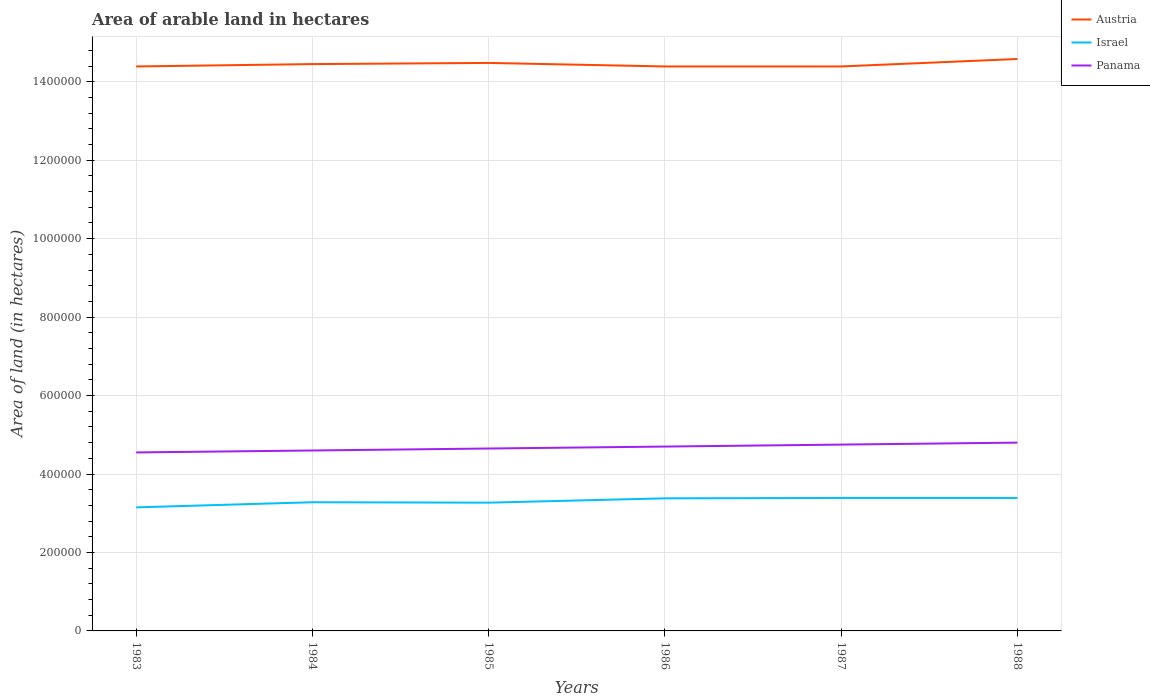Across all years, what is the maximum total arable land in Panama?
Give a very brief answer. 4.55e+05. In which year was the total arable land in Israel maximum?
Your response must be concise. 1983. What is the total total arable land in Austria in the graph?
Provide a succinct answer. -1.30e+04. What is the difference between the highest and the second highest total arable land in Israel?
Provide a succinct answer. 2.40e+04. What is the difference between the highest and the lowest total arable land in Israel?
Offer a terse response. 3. How many years are there in the graph?
Your response must be concise. 6. Does the graph contain any zero values?
Your response must be concise. No. Does the graph contain grids?
Your answer should be very brief. Yes. Where does the legend appear in the graph?
Your answer should be very brief. Top right. How are the legend labels stacked?
Offer a terse response. Vertical. What is the title of the graph?
Offer a very short reply. Area of arable land in hectares. Does "Faeroe Islands" appear as one of the legend labels in the graph?
Offer a very short reply. No. What is the label or title of the Y-axis?
Ensure brevity in your answer.  Area of land (in hectares). What is the Area of land (in hectares) of Austria in 1983?
Ensure brevity in your answer.  1.44e+06. What is the Area of land (in hectares) of Israel in 1983?
Offer a very short reply. 3.15e+05. What is the Area of land (in hectares) in Panama in 1983?
Ensure brevity in your answer.  4.55e+05. What is the Area of land (in hectares) in Austria in 1984?
Make the answer very short. 1.44e+06. What is the Area of land (in hectares) of Israel in 1984?
Offer a terse response. 3.28e+05. What is the Area of land (in hectares) of Austria in 1985?
Provide a succinct answer. 1.45e+06. What is the Area of land (in hectares) in Israel in 1985?
Give a very brief answer. 3.27e+05. What is the Area of land (in hectares) of Panama in 1985?
Give a very brief answer. 4.65e+05. What is the Area of land (in hectares) in Austria in 1986?
Make the answer very short. 1.44e+06. What is the Area of land (in hectares) in Israel in 1986?
Your answer should be compact. 3.38e+05. What is the Area of land (in hectares) in Panama in 1986?
Ensure brevity in your answer.  4.70e+05. What is the Area of land (in hectares) in Austria in 1987?
Provide a short and direct response. 1.44e+06. What is the Area of land (in hectares) of Israel in 1987?
Keep it short and to the point. 3.39e+05. What is the Area of land (in hectares) in Panama in 1987?
Make the answer very short. 4.75e+05. What is the Area of land (in hectares) in Austria in 1988?
Make the answer very short. 1.46e+06. What is the Area of land (in hectares) of Israel in 1988?
Provide a succinct answer. 3.39e+05. What is the Area of land (in hectares) of Panama in 1988?
Give a very brief answer. 4.80e+05. Across all years, what is the maximum Area of land (in hectares) in Austria?
Provide a succinct answer. 1.46e+06. Across all years, what is the maximum Area of land (in hectares) of Israel?
Your response must be concise. 3.39e+05. Across all years, what is the minimum Area of land (in hectares) of Austria?
Offer a very short reply. 1.44e+06. Across all years, what is the minimum Area of land (in hectares) in Israel?
Make the answer very short. 3.15e+05. Across all years, what is the minimum Area of land (in hectares) in Panama?
Provide a short and direct response. 4.55e+05. What is the total Area of land (in hectares) in Austria in the graph?
Offer a very short reply. 8.67e+06. What is the total Area of land (in hectares) in Israel in the graph?
Your answer should be very brief. 1.99e+06. What is the total Area of land (in hectares) in Panama in the graph?
Your answer should be compact. 2.80e+06. What is the difference between the Area of land (in hectares) in Austria in 1983 and that in 1984?
Ensure brevity in your answer.  -6000. What is the difference between the Area of land (in hectares) of Israel in 1983 and that in 1984?
Provide a short and direct response. -1.30e+04. What is the difference between the Area of land (in hectares) of Panama in 1983 and that in 1984?
Offer a terse response. -5000. What is the difference between the Area of land (in hectares) of Austria in 1983 and that in 1985?
Your response must be concise. -9000. What is the difference between the Area of land (in hectares) in Israel in 1983 and that in 1985?
Keep it short and to the point. -1.20e+04. What is the difference between the Area of land (in hectares) in Panama in 1983 and that in 1985?
Keep it short and to the point. -10000. What is the difference between the Area of land (in hectares) of Austria in 1983 and that in 1986?
Provide a short and direct response. 0. What is the difference between the Area of land (in hectares) in Israel in 1983 and that in 1986?
Provide a succinct answer. -2.30e+04. What is the difference between the Area of land (in hectares) in Panama in 1983 and that in 1986?
Make the answer very short. -1.50e+04. What is the difference between the Area of land (in hectares) of Israel in 1983 and that in 1987?
Your answer should be very brief. -2.40e+04. What is the difference between the Area of land (in hectares) in Austria in 1983 and that in 1988?
Offer a very short reply. -1.90e+04. What is the difference between the Area of land (in hectares) of Israel in 1983 and that in 1988?
Ensure brevity in your answer.  -2.40e+04. What is the difference between the Area of land (in hectares) in Panama in 1983 and that in 1988?
Offer a terse response. -2.50e+04. What is the difference between the Area of land (in hectares) of Austria in 1984 and that in 1985?
Your response must be concise. -3000. What is the difference between the Area of land (in hectares) of Panama in 1984 and that in 1985?
Offer a terse response. -5000. What is the difference between the Area of land (in hectares) of Austria in 1984 and that in 1986?
Provide a succinct answer. 6000. What is the difference between the Area of land (in hectares) of Israel in 1984 and that in 1986?
Give a very brief answer. -10000. What is the difference between the Area of land (in hectares) in Panama in 1984 and that in 1986?
Your answer should be very brief. -10000. What is the difference between the Area of land (in hectares) of Austria in 1984 and that in 1987?
Give a very brief answer. 6000. What is the difference between the Area of land (in hectares) of Israel in 1984 and that in 1987?
Keep it short and to the point. -1.10e+04. What is the difference between the Area of land (in hectares) of Panama in 1984 and that in 1987?
Give a very brief answer. -1.50e+04. What is the difference between the Area of land (in hectares) of Austria in 1984 and that in 1988?
Provide a short and direct response. -1.30e+04. What is the difference between the Area of land (in hectares) in Israel in 1984 and that in 1988?
Keep it short and to the point. -1.10e+04. What is the difference between the Area of land (in hectares) of Austria in 1985 and that in 1986?
Provide a short and direct response. 9000. What is the difference between the Area of land (in hectares) of Israel in 1985 and that in 1986?
Offer a terse response. -1.10e+04. What is the difference between the Area of land (in hectares) of Panama in 1985 and that in 1986?
Your response must be concise. -5000. What is the difference between the Area of land (in hectares) in Austria in 1985 and that in 1987?
Your response must be concise. 9000. What is the difference between the Area of land (in hectares) of Israel in 1985 and that in 1987?
Your answer should be compact. -1.20e+04. What is the difference between the Area of land (in hectares) of Panama in 1985 and that in 1987?
Provide a succinct answer. -10000. What is the difference between the Area of land (in hectares) in Israel in 1985 and that in 1988?
Your answer should be very brief. -1.20e+04. What is the difference between the Area of land (in hectares) of Panama in 1985 and that in 1988?
Your response must be concise. -1.50e+04. What is the difference between the Area of land (in hectares) in Austria in 1986 and that in 1987?
Your response must be concise. 0. What is the difference between the Area of land (in hectares) in Israel in 1986 and that in 1987?
Provide a succinct answer. -1000. What is the difference between the Area of land (in hectares) in Panama in 1986 and that in 1987?
Provide a succinct answer. -5000. What is the difference between the Area of land (in hectares) of Austria in 1986 and that in 1988?
Ensure brevity in your answer.  -1.90e+04. What is the difference between the Area of land (in hectares) of Israel in 1986 and that in 1988?
Offer a terse response. -1000. What is the difference between the Area of land (in hectares) in Austria in 1987 and that in 1988?
Give a very brief answer. -1.90e+04. What is the difference between the Area of land (in hectares) in Panama in 1987 and that in 1988?
Offer a very short reply. -5000. What is the difference between the Area of land (in hectares) in Austria in 1983 and the Area of land (in hectares) in Israel in 1984?
Make the answer very short. 1.11e+06. What is the difference between the Area of land (in hectares) in Austria in 1983 and the Area of land (in hectares) in Panama in 1984?
Offer a terse response. 9.79e+05. What is the difference between the Area of land (in hectares) in Israel in 1983 and the Area of land (in hectares) in Panama in 1984?
Your answer should be compact. -1.45e+05. What is the difference between the Area of land (in hectares) in Austria in 1983 and the Area of land (in hectares) in Israel in 1985?
Your answer should be compact. 1.11e+06. What is the difference between the Area of land (in hectares) in Austria in 1983 and the Area of land (in hectares) in Panama in 1985?
Offer a very short reply. 9.74e+05. What is the difference between the Area of land (in hectares) of Israel in 1983 and the Area of land (in hectares) of Panama in 1985?
Offer a terse response. -1.50e+05. What is the difference between the Area of land (in hectares) in Austria in 1983 and the Area of land (in hectares) in Israel in 1986?
Give a very brief answer. 1.10e+06. What is the difference between the Area of land (in hectares) in Austria in 1983 and the Area of land (in hectares) in Panama in 1986?
Provide a succinct answer. 9.69e+05. What is the difference between the Area of land (in hectares) in Israel in 1983 and the Area of land (in hectares) in Panama in 1986?
Offer a very short reply. -1.55e+05. What is the difference between the Area of land (in hectares) of Austria in 1983 and the Area of land (in hectares) of Israel in 1987?
Offer a very short reply. 1.10e+06. What is the difference between the Area of land (in hectares) in Austria in 1983 and the Area of land (in hectares) in Panama in 1987?
Your response must be concise. 9.64e+05. What is the difference between the Area of land (in hectares) of Austria in 1983 and the Area of land (in hectares) of Israel in 1988?
Your answer should be compact. 1.10e+06. What is the difference between the Area of land (in hectares) in Austria in 1983 and the Area of land (in hectares) in Panama in 1988?
Provide a succinct answer. 9.59e+05. What is the difference between the Area of land (in hectares) in Israel in 1983 and the Area of land (in hectares) in Panama in 1988?
Keep it short and to the point. -1.65e+05. What is the difference between the Area of land (in hectares) in Austria in 1984 and the Area of land (in hectares) in Israel in 1985?
Ensure brevity in your answer.  1.12e+06. What is the difference between the Area of land (in hectares) in Austria in 1984 and the Area of land (in hectares) in Panama in 1985?
Offer a terse response. 9.80e+05. What is the difference between the Area of land (in hectares) in Israel in 1984 and the Area of land (in hectares) in Panama in 1985?
Make the answer very short. -1.37e+05. What is the difference between the Area of land (in hectares) in Austria in 1984 and the Area of land (in hectares) in Israel in 1986?
Your response must be concise. 1.11e+06. What is the difference between the Area of land (in hectares) of Austria in 1984 and the Area of land (in hectares) of Panama in 1986?
Your answer should be very brief. 9.75e+05. What is the difference between the Area of land (in hectares) of Israel in 1984 and the Area of land (in hectares) of Panama in 1986?
Your response must be concise. -1.42e+05. What is the difference between the Area of land (in hectares) in Austria in 1984 and the Area of land (in hectares) in Israel in 1987?
Ensure brevity in your answer.  1.11e+06. What is the difference between the Area of land (in hectares) in Austria in 1984 and the Area of land (in hectares) in Panama in 1987?
Offer a very short reply. 9.70e+05. What is the difference between the Area of land (in hectares) of Israel in 1984 and the Area of land (in hectares) of Panama in 1987?
Give a very brief answer. -1.47e+05. What is the difference between the Area of land (in hectares) in Austria in 1984 and the Area of land (in hectares) in Israel in 1988?
Your answer should be very brief. 1.11e+06. What is the difference between the Area of land (in hectares) of Austria in 1984 and the Area of land (in hectares) of Panama in 1988?
Ensure brevity in your answer.  9.65e+05. What is the difference between the Area of land (in hectares) of Israel in 1984 and the Area of land (in hectares) of Panama in 1988?
Your response must be concise. -1.52e+05. What is the difference between the Area of land (in hectares) of Austria in 1985 and the Area of land (in hectares) of Israel in 1986?
Provide a short and direct response. 1.11e+06. What is the difference between the Area of land (in hectares) of Austria in 1985 and the Area of land (in hectares) of Panama in 1986?
Give a very brief answer. 9.78e+05. What is the difference between the Area of land (in hectares) of Israel in 1985 and the Area of land (in hectares) of Panama in 1986?
Your answer should be very brief. -1.43e+05. What is the difference between the Area of land (in hectares) of Austria in 1985 and the Area of land (in hectares) of Israel in 1987?
Give a very brief answer. 1.11e+06. What is the difference between the Area of land (in hectares) in Austria in 1985 and the Area of land (in hectares) in Panama in 1987?
Offer a very short reply. 9.73e+05. What is the difference between the Area of land (in hectares) in Israel in 1985 and the Area of land (in hectares) in Panama in 1987?
Provide a succinct answer. -1.48e+05. What is the difference between the Area of land (in hectares) in Austria in 1985 and the Area of land (in hectares) in Israel in 1988?
Provide a short and direct response. 1.11e+06. What is the difference between the Area of land (in hectares) in Austria in 1985 and the Area of land (in hectares) in Panama in 1988?
Provide a short and direct response. 9.68e+05. What is the difference between the Area of land (in hectares) in Israel in 1985 and the Area of land (in hectares) in Panama in 1988?
Offer a very short reply. -1.53e+05. What is the difference between the Area of land (in hectares) of Austria in 1986 and the Area of land (in hectares) of Israel in 1987?
Provide a short and direct response. 1.10e+06. What is the difference between the Area of land (in hectares) of Austria in 1986 and the Area of land (in hectares) of Panama in 1987?
Your answer should be very brief. 9.64e+05. What is the difference between the Area of land (in hectares) in Israel in 1986 and the Area of land (in hectares) in Panama in 1987?
Offer a very short reply. -1.37e+05. What is the difference between the Area of land (in hectares) in Austria in 1986 and the Area of land (in hectares) in Israel in 1988?
Make the answer very short. 1.10e+06. What is the difference between the Area of land (in hectares) of Austria in 1986 and the Area of land (in hectares) of Panama in 1988?
Your answer should be very brief. 9.59e+05. What is the difference between the Area of land (in hectares) in Israel in 1986 and the Area of land (in hectares) in Panama in 1988?
Offer a very short reply. -1.42e+05. What is the difference between the Area of land (in hectares) of Austria in 1987 and the Area of land (in hectares) of Israel in 1988?
Make the answer very short. 1.10e+06. What is the difference between the Area of land (in hectares) of Austria in 1987 and the Area of land (in hectares) of Panama in 1988?
Ensure brevity in your answer.  9.59e+05. What is the difference between the Area of land (in hectares) in Israel in 1987 and the Area of land (in hectares) in Panama in 1988?
Give a very brief answer. -1.41e+05. What is the average Area of land (in hectares) of Austria per year?
Your answer should be compact. 1.44e+06. What is the average Area of land (in hectares) in Israel per year?
Offer a very short reply. 3.31e+05. What is the average Area of land (in hectares) in Panama per year?
Your answer should be very brief. 4.68e+05. In the year 1983, what is the difference between the Area of land (in hectares) of Austria and Area of land (in hectares) of Israel?
Your response must be concise. 1.12e+06. In the year 1983, what is the difference between the Area of land (in hectares) of Austria and Area of land (in hectares) of Panama?
Ensure brevity in your answer.  9.84e+05. In the year 1983, what is the difference between the Area of land (in hectares) of Israel and Area of land (in hectares) of Panama?
Give a very brief answer. -1.40e+05. In the year 1984, what is the difference between the Area of land (in hectares) of Austria and Area of land (in hectares) of Israel?
Your response must be concise. 1.12e+06. In the year 1984, what is the difference between the Area of land (in hectares) of Austria and Area of land (in hectares) of Panama?
Your answer should be very brief. 9.85e+05. In the year 1984, what is the difference between the Area of land (in hectares) in Israel and Area of land (in hectares) in Panama?
Give a very brief answer. -1.32e+05. In the year 1985, what is the difference between the Area of land (in hectares) in Austria and Area of land (in hectares) in Israel?
Make the answer very short. 1.12e+06. In the year 1985, what is the difference between the Area of land (in hectares) in Austria and Area of land (in hectares) in Panama?
Offer a terse response. 9.83e+05. In the year 1985, what is the difference between the Area of land (in hectares) in Israel and Area of land (in hectares) in Panama?
Your answer should be compact. -1.38e+05. In the year 1986, what is the difference between the Area of land (in hectares) in Austria and Area of land (in hectares) in Israel?
Ensure brevity in your answer.  1.10e+06. In the year 1986, what is the difference between the Area of land (in hectares) in Austria and Area of land (in hectares) in Panama?
Ensure brevity in your answer.  9.69e+05. In the year 1986, what is the difference between the Area of land (in hectares) of Israel and Area of land (in hectares) of Panama?
Keep it short and to the point. -1.32e+05. In the year 1987, what is the difference between the Area of land (in hectares) in Austria and Area of land (in hectares) in Israel?
Provide a short and direct response. 1.10e+06. In the year 1987, what is the difference between the Area of land (in hectares) in Austria and Area of land (in hectares) in Panama?
Your answer should be very brief. 9.64e+05. In the year 1987, what is the difference between the Area of land (in hectares) of Israel and Area of land (in hectares) of Panama?
Keep it short and to the point. -1.36e+05. In the year 1988, what is the difference between the Area of land (in hectares) in Austria and Area of land (in hectares) in Israel?
Your answer should be very brief. 1.12e+06. In the year 1988, what is the difference between the Area of land (in hectares) of Austria and Area of land (in hectares) of Panama?
Offer a very short reply. 9.78e+05. In the year 1988, what is the difference between the Area of land (in hectares) of Israel and Area of land (in hectares) of Panama?
Your answer should be compact. -1.41e+05. What is the ratio of the Area of land (in hectares) of Israel in 1983 to that in 1984?
Provide a short and direct response. 0.96. What is the ratio of the Area of land (in hectares) of Panama in 1983 to that in 1984?
Provide a short and direct response. 0.99. What is the ratio of the Area of land (in hectares) in Austria in 1983 to that in 1985?
Make the answer very short. 0.99. What is the ratio of the Area of land (in hectares) in Israel in 1983 to that in 1985?
Your answer should be compact. 0.96. What is the ratio of the Area of land (in hectares) of Panama in 1983 to that in 1985?
Your answer should be compact. 0.98. What is the ratio of the Area of land (in hectares) in Austria in 1983 to that in 1986?
Give a very brief answer. 1. What is the ratio of the Area of land (in hectares) of Israel in 1983 to that in 1986?
Ensure brevity in your answer.  0.93. What is the ratio of the Area of land (in hectares) in Panama in 1983 to that in 1986?
Offer a very short reply. 0.97. What is the ratio of the Area of land (in hectares) of Austria in 1983 to that in 1987?
Your answer should be compact. 1. What is the ratio of the Area of land (in hectares) of Israel in 1983 to that in 1987?
Give a very brief answer. 0.93. What is the ratio of the Area of land (in hectares) in Panama in 1983 to that in 1987?
Your answer should be compact. 0.96. What is the ratio of the Area of land (in hectares) of Israel in 1983 to that in 1988?
Offer a terse response. 0.93. What is the ratio of the Area of land (in hectares) of Panama in 1983 to that in 1988?
Make the answer very short. 0.95. What is the ratio of the Area of land (in hectares) in Israel in 1984 to that in 1985?
Ensure brevity in your answer.  1. What is the ratio of the Area of land (in hectares) in Austria in 1984 to that in 1986?
Ensure brevity in your answer.  1. What is the ratio of the Area of land (in hectares) of Israel in 1984 to that in 1986?
Your answer should be very brief. 0.97. What is the ratio of the Area of land (in hectares) in Panama in 1984 to that in 1986?
Provide a short and direct response. 0.98. What is the ratio of the Area of land (in hectares) of Israel in 1984 to that in 1987?
Your answer should be very brief. 0.97. What is the ratio of the Area of land (in hectares) in Panama in 1984 to that in 1987?
Provide a short and direct response. 0.97. What is the ratio of the Area of land (in hectares) in Austria in 1984 to that in 1988?
Make the answer very short. 0.99. What is the ratio of the Area of land (in hectares) of Israel in 1984 to that in 1988?
Your answer should be very brief. 0.97. What is the ratio of the Area of land (in hectares) of Panama in 1984 to that in 1988?
Provide a succinct answer. 0.96. What is the ratio of the Area of land (in hectares) of Israel in 1985 to that in 1986?
Offer a very short reply. 0.97. What is the ratio of the Area of land (in hectares) in Panama in 1985 to that in 1986?
Your answer should be compact. 0.99. What is the ratio of the Area of land (in hectares) of Austria in 1985 to that in 1987?
Make the answer very short. 1.01. What is the ratio of the Area of land (in hectares) of Israel in 1985 to that in 1987?
Provide a succinct answer. 0.96. What is the ratio of the Area of land (in hectares) of Panama in 1985 to that in 1987?
Provide a short and direct response. 0.98. What is the ratio of the Area of land (in hectares) in Israel in 1985 to that in 1988?
Ensure brevity in your answer.  0.96. What is the ratio of the Area of land (in hectares) in Panama in 1985 to that in 1988?
Offer a terse response. 0.97. What is the ratio of the Area of land (in hectares) in Austria in 1986 to that in 1987?
Your answer should be very brief. 1. What is the ratio of the Area of land (in hectares) in Panama in 1986 to that in 1987?
Make the answer very short. 0.99. What is the ratio of the Area of land (in hectares) in Panama in 1986 to that in 1988?
Make the answer very short. 0.98. What is the ratio of the Area of land (in hectares) in Austria in 1987 to that in 1988?
Offer a very short reply. 0.99. What is the ratio of the Area of land (in hectares) in Israel in 1987 to that in 1988?
Give a very brief answer. 1. What is the ratio of the Area of land (in hectares) of Panama in 1987 to that in 1988?
Ensure brevity in your answer.  0.99. What is the difference between the highest and the second highest Area of land (in hectares) in Israel?
Your answer should be compact. 0. What is the difference between the highest and the lowest Area of land (in hectares) of Austria?
Provide a short and direct response. 1.90e+04. What is the difference between the highest and the lowest Area of land (in hectares) in Israel?
Your answer should be compact. 2.40e+04. What is the difference between the highest and the lowest Area of land (in hectares) of Panama?
Your answer should be very brief. 2.50e+04. 